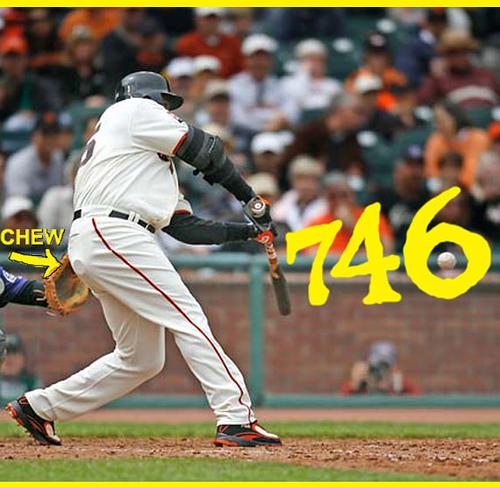What number is on the screen?
Write a very short answer. 746. What is the man doing?
Be succinct. Batting. What sport is being played?
Quick response, please. Baseball. What is the number on the photo?
Give a very brief answer. 746. 